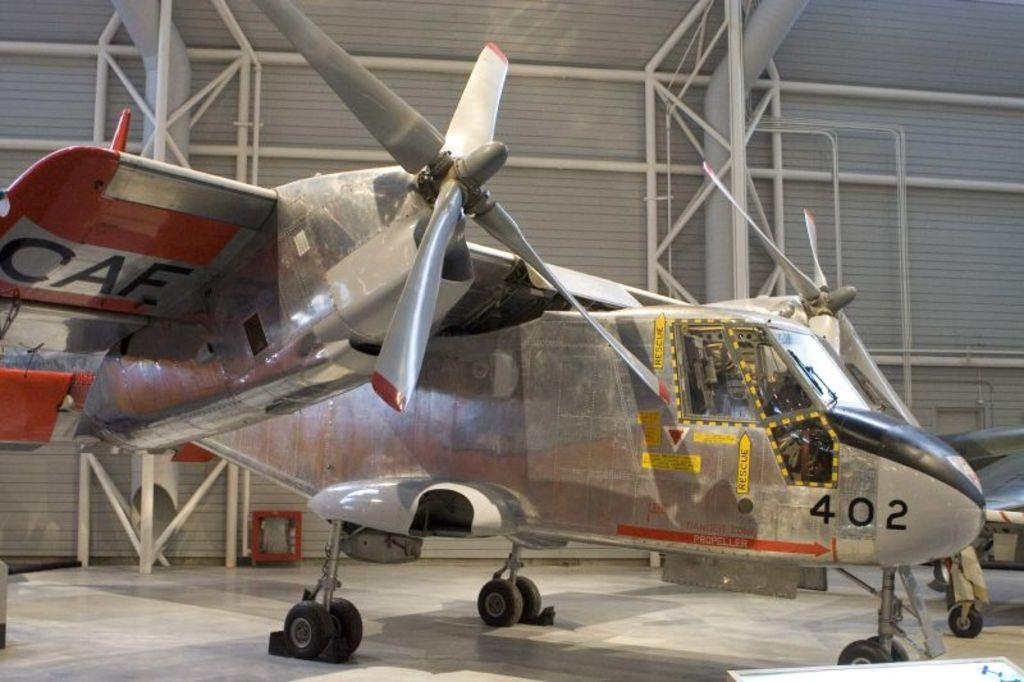<image>
Relay a brief, clear account of the picture shown. A silver airplane bearing the number 402 on its nose sits in a bright and spacious hangar. 